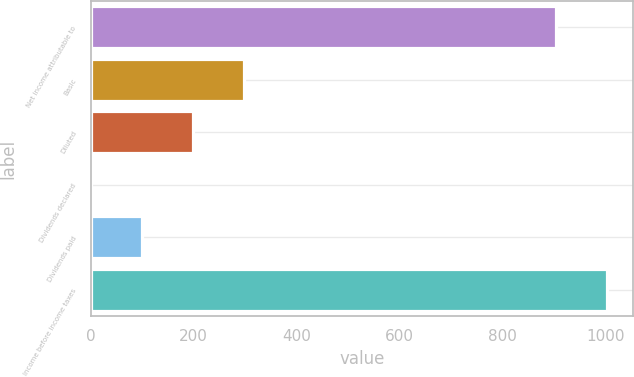Convert chart. <chart><loc_0><loc_0><loc_500><loc_500><bar_chart><fcel>Net income attributable to<fcel>Basic<fcel>Diluted<fcel>Dividends declared<fcel>Dividends paid<fcel>Income before income taxes<nl><fcel>904<fcel>296.96<fcel>198.09<fcel>0.35<fcel>99.22<fcel>1002.87<nl></chart> 